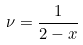<formula> <loc_0><loc_0><loc_500><loc_500>\nu = \frac { 1 } { 2 - x }</formula> 